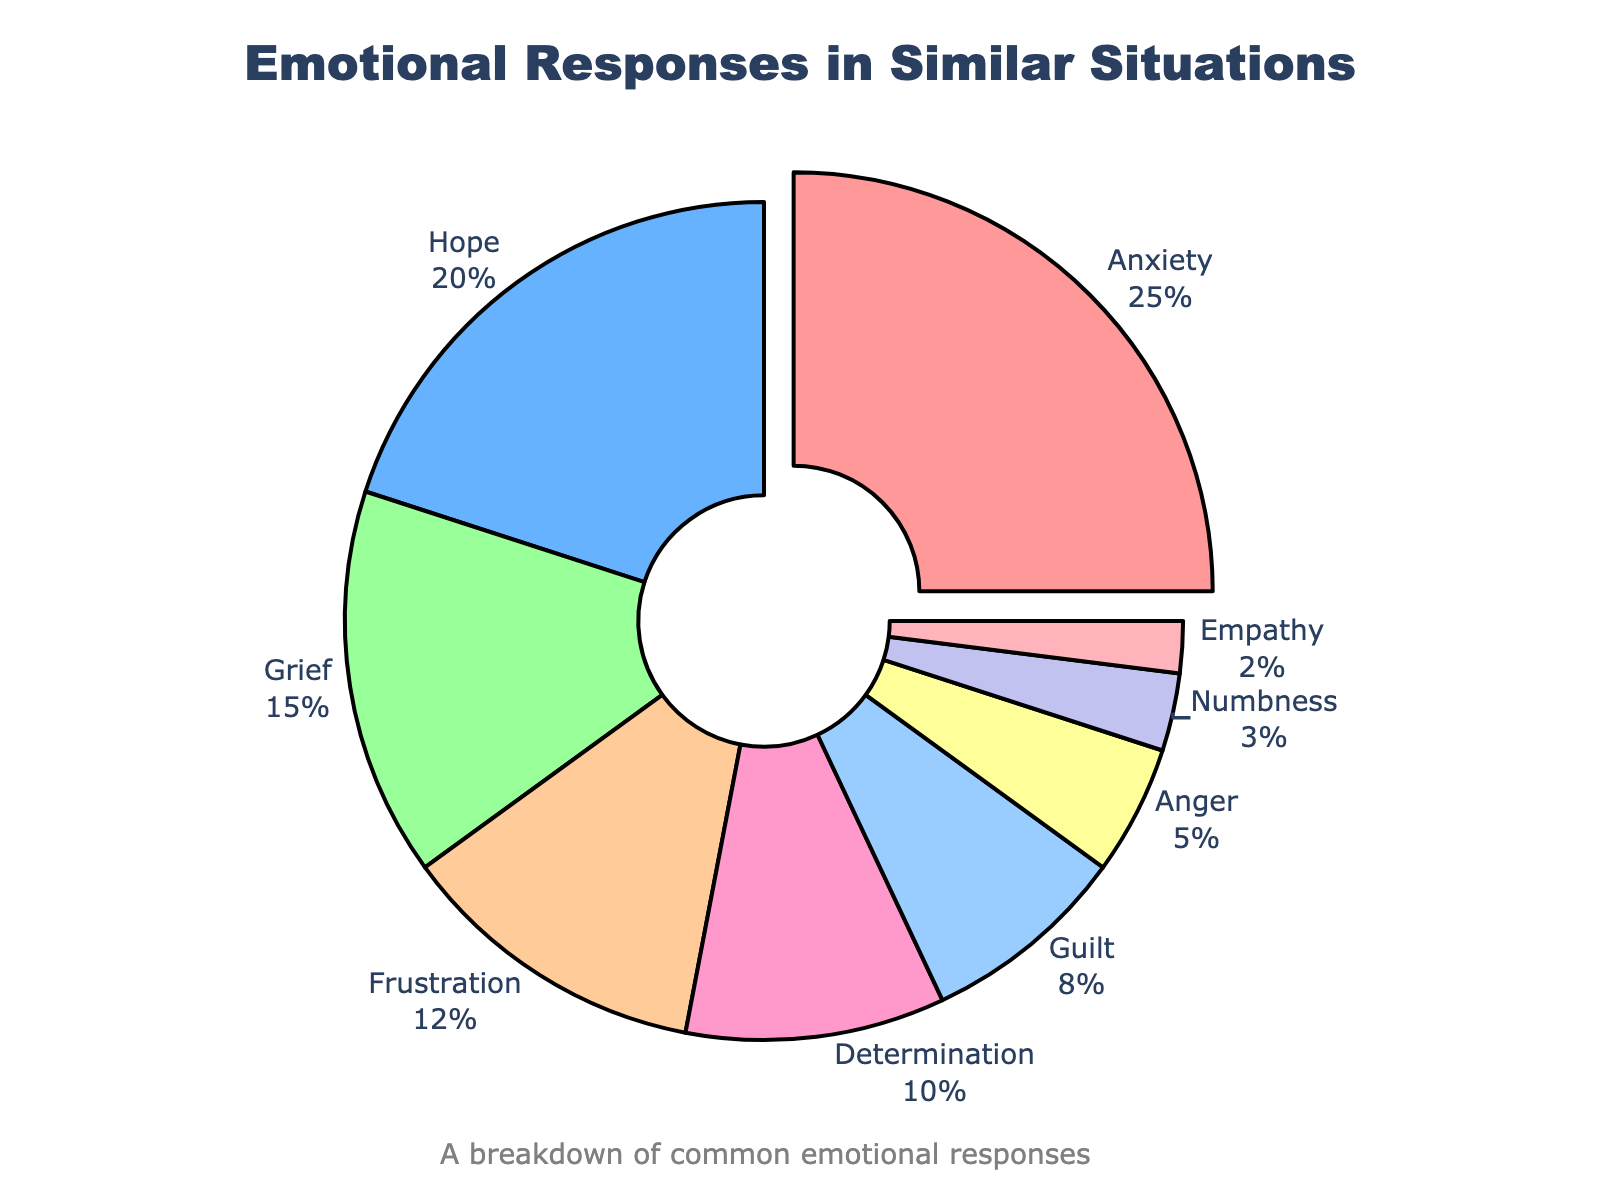What is the most common emotional response? The figure highlights the most common emotional response by pulling its section out. Anxiety accounts for the largest percentage at 25%.
Answer: Anxiety What percentage of individuals experienced hope or grief? According to the figure, the percentage of individuals experiencing hope is 20%, and the percentage for grief is 15%. Adding these together gives 20% + 15% = 35%.
Answer: 35% Which emotion is more prevalent: frustration or guilt? By comparing the percentages in the pie chart, frustration has 12% while guilt has 8%. Therefore, frustration is more prevalent.
Answer: Frustration What is the total percentage for empathy, numbness, and anger combined? Adding the percentages for empathy (2%), numbness (3%), and anger (5%) gives us 2% + 3% + 5% = 10%.
Answer: 10% How does the percentage of determination compare to guilt? Determination accounts for 10% and guilt accounts for 8%. Therefore, determination has 2% more than guilt.
Answer: 2% more What are the percentages of the two least common emotional responses? The pie chart shows that empathy (2%) and numbness (3%) are the least common emotional responses.
Answer: 2% and 3% Which color represents anger, and what percentage does it account for? The color representing anger is identified as the section in the pie chart with a percentage of 5%. This section is colored in a specific shade as indicated by the figure.
Answer: 5% What is the combined share of anxiety, hope, and grief? Summing up the percentages for anxiety (25%), hope (20%), and grief (15%) results in a combined percentage of 60%.
Answer: 60% Is empathy or anger a more common response, and by how much? Comparing the pie chart, empathy accounts for 2% and anger accounts for 5%. Anger is 3% more common than empathy.
Answer: Anger by 3% What emotional response has a percentage just lower than that of frustration? The figure lists frustration at 12%. The next lower percentage for emotional responses is determination, at 10%.
Answer: Determination 